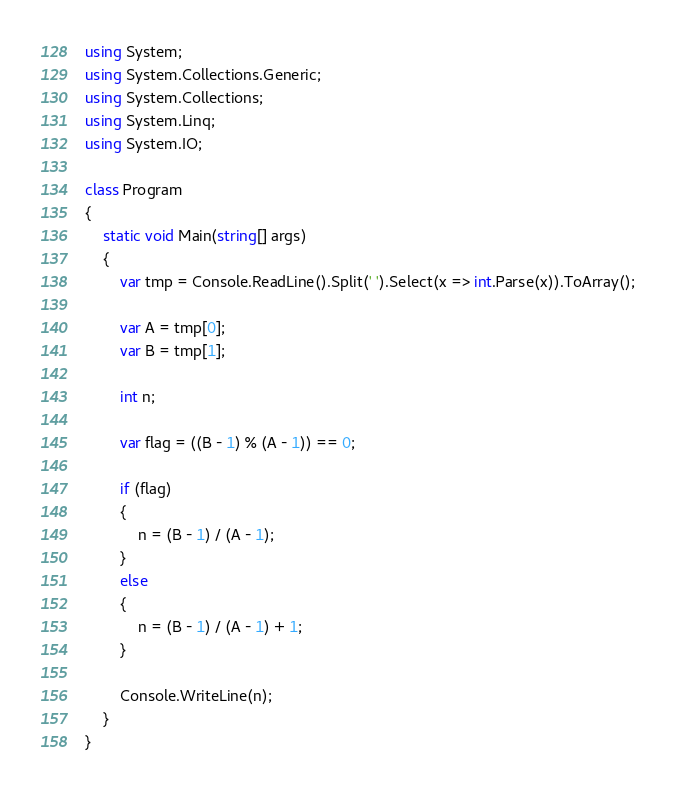<code> <loc_0><loc_0><loc_500><loc_500><_C#_>using System;
using System.Collections.Generic;
using System.Collections;
using System.Linq;
using System.IO;

class Program
{
    static void Main(string[] args)
    {
        var tmp = Console.ReadLine().Split(' ').Select(x => int.Parse(x)).ToArray();

        var A = tmp[0];
        var B = tmp[1];

        int n;

        var flag = ((B - 1) % (A - 1)) == 0;

        if (flag)
        {
            n = (B - 1) / (A - 1);
        }
        else
        {
            n = (B - 1) / (A - 1) + 1;
        }

        Console.WriteLine(n);
    }
}
</code> 